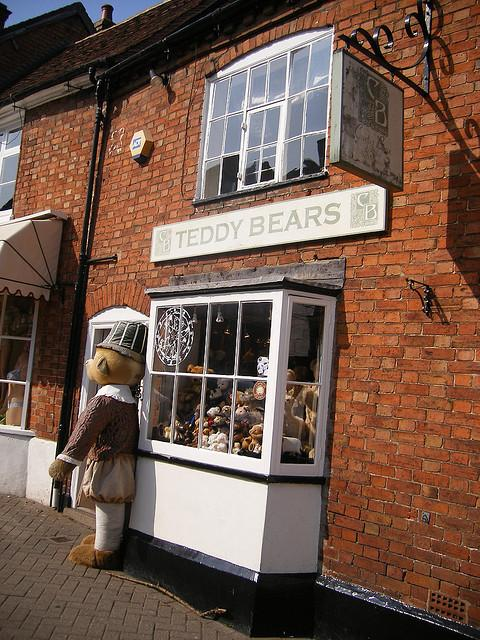What stuffed animal is sold here?

Choices:
A) dogs
B) bears
C) cats
D) rabbit bears 